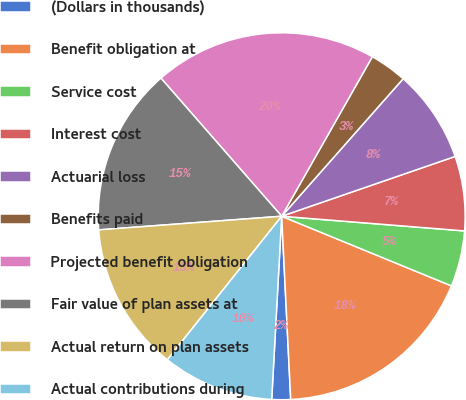Convert chart. <chart><loc_0><loc_0><loc_500><loc_500><pie_chart><fcel>(Dollars in thousands)<fcel>Benefit obligation at<fcel>Service cost<fcel>Interest cost<fcel>Actuarial loss<fcel>Benefits paid<fcel>Projected benefit obligation<fcel>Fair value of plan assets at<fcel>Actual return on plan assets<fcel>Actual contributions during<nl><fcel>1.65%<fcel>18.02%<fcel>4.92%<fcel>6.56%<fcel>8.2%<fcel>3.29%<fcel>19.66%<fcel>14.75%<fcel>13.11%<fcel>9.84%<nl></chart> 